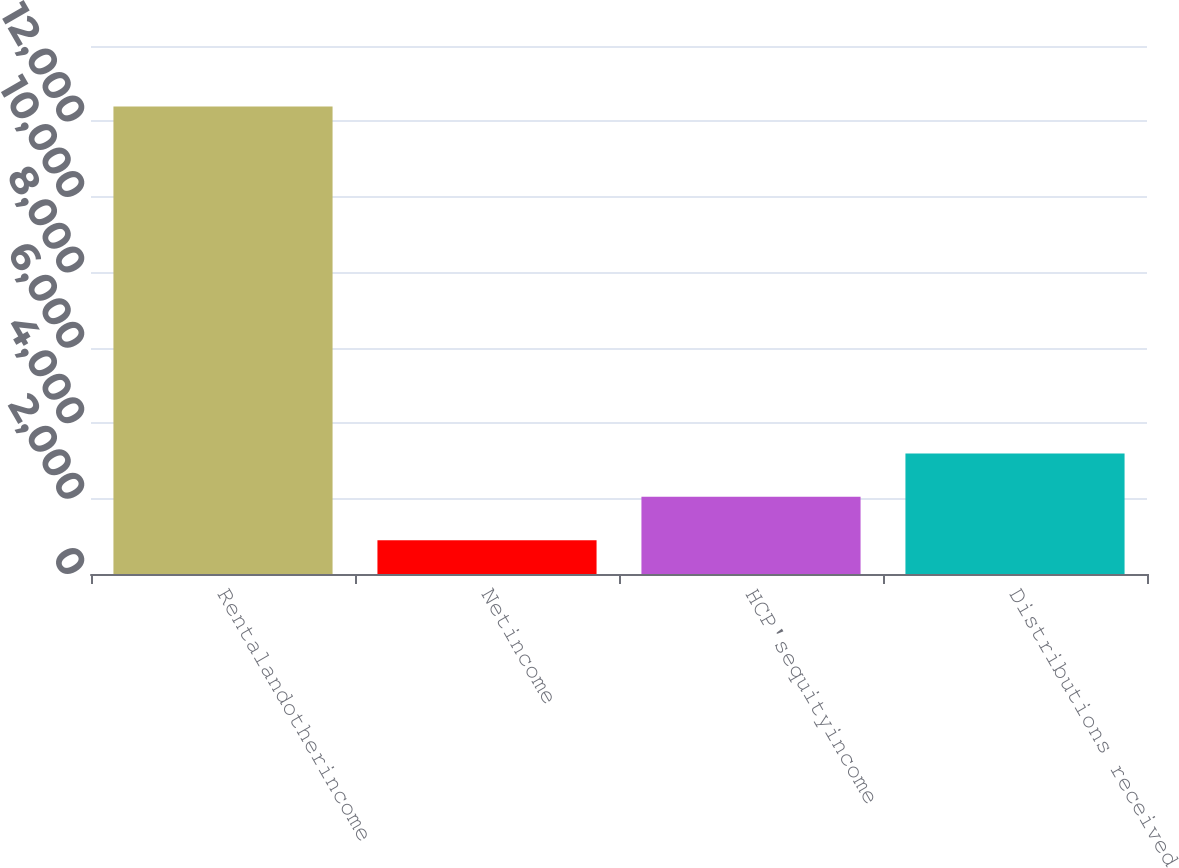Convert chart to OTSL. <chart><loc_0><loc_0><loc_500><loc_500><bar_chart><fcel>Rentalandotherincome<fcel>Netincome<fcel>HCP'sequityincome<fcel>Distributions received<nl><fcel>12397<fcel>895<fcel>2045.2<fcel>3195.4<nl></chart> 